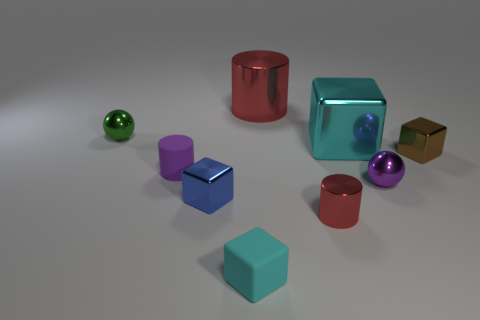Subtract 1 cubes. How many cubes are left? 3 Subtract all blue blocks. How many blocks are left? 3 Subtract all blue cubes. How many cubes are left? 3 Add 1 big red matte balls. How many objects exist? 10 Subtract all purple blocks. Subtract all red spheres. How many blocks are left? 4 Subtract all cylinders. How many objects are left? 6 Subtract 1 purple cylinders. How many objects are left? 8 Subtract all blue matte cubes. Subtract all small purple rubber things. How many objects are left? 8 Add 3 large red metallic things. How many large red metallic things are left? 4 Add 3 small matte cylinders. How many small matte cylinders exist? 4 